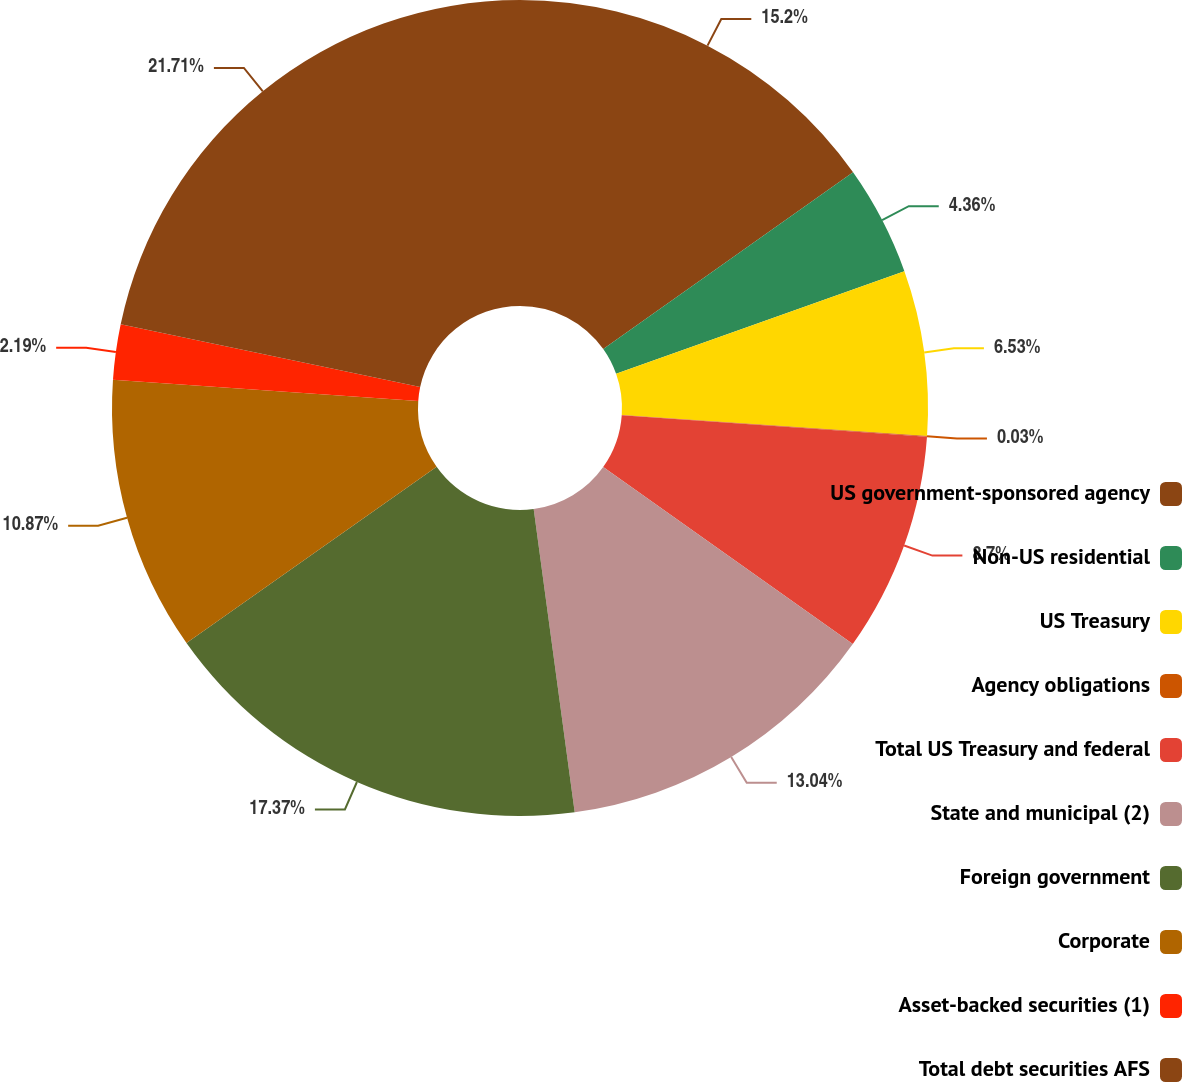<chart> <loc_0><loc_0><loc_500><loc_500><pie_chart><fcel>US government-sponsored agency<fcel>Non-US residential<fcel>US Treasury<fcel>Agency obligations<fcel>Total US Treasury and federal<fcel>State and municipal (2)<fcel>Foreign government<fcel>Corporate<fcel>Asset-backed securities (1)<fcel>Total debt securities AFS<nl><fcel>15.2%<fcel>4.36%<fcel>6.53%<fcel>0.03%<fcel>8.7%<fcel>13.04%<fcel>17.37%<fcel>10.87%<fcel>2.19%<fcel>21.71%<nl></chart> 